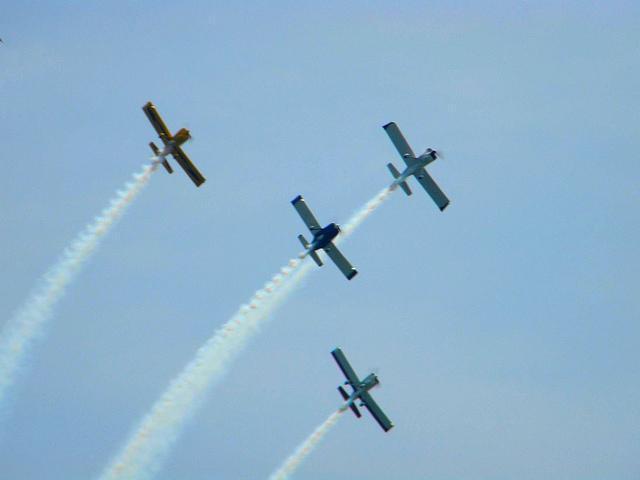How many planes are flying?
Give a very brief answer. 4. 